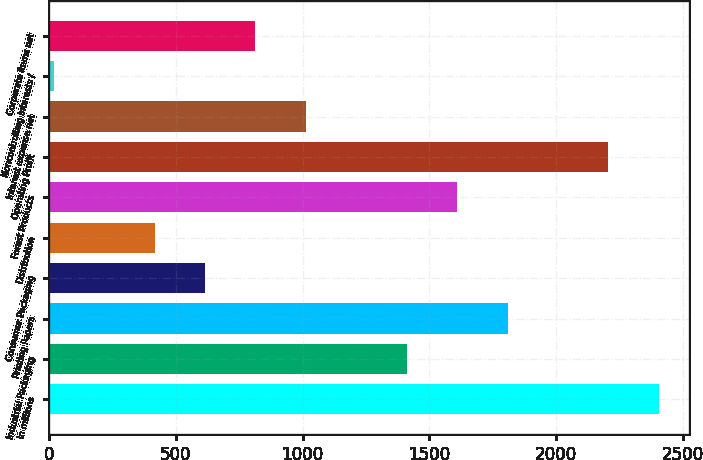Convert chart. <chart><loc_0><loc_0><loc_500><loc_500><bar_chart><fcel>In millions<fcel>Industrial Packaging<fcel>Printing Papers<fcel>Consumer Packaging<fcel>Distribution<fcel>Forest Products<fcel>Operating Profit<fcel>Interest expense net<fcel>Noncontrolling interests /<fcel>Corporate items net<nl><fcel>2404.6<fcel>1410.6<fcel>1808.2<fcel>615.4<fcel>416.6<fcel>1609.4<fcel>2205.8<fcel>1013<fcel>19<fcel>814.2<nl></chart> 